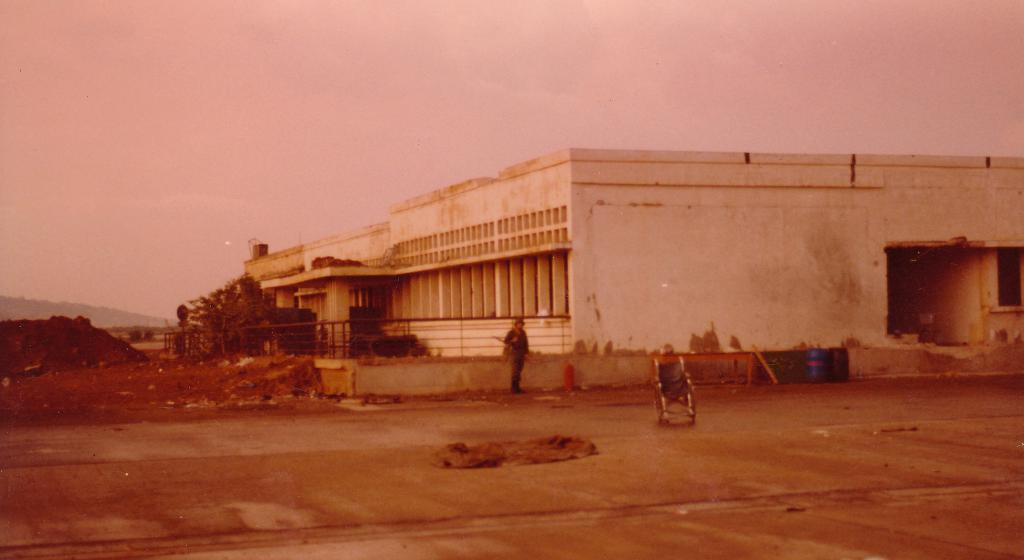How would you summarize this image in a sentence or two? In this image we can see a building with several pillars and a fence. We can also see a wheel chair and a person standing on the ground, a tree, a heap of mud and the sky which looks cloudy. 